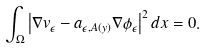<formula> <loc_0><loc_0><loc_500><loc_500>\int _ { \Omega } \left | \nabla v _ { \epsilon } - a _ { \epsilon , A ( y ) } \nabla \phi _ { \epsilon } \right | ^ { 2 } d x = 0 .</formula> 